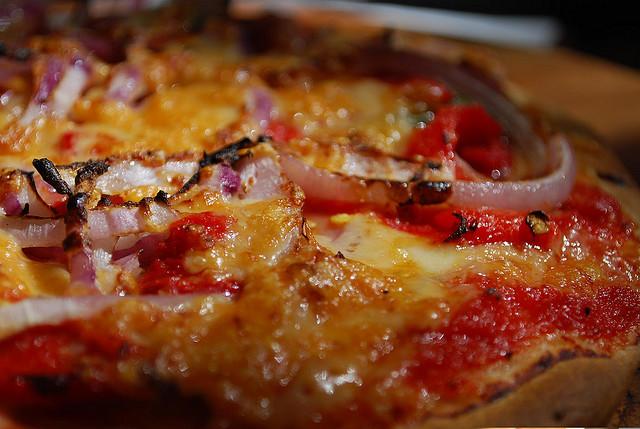Are the onions raw or cooked?
Be succinct. Cooked. Do you like broccoli?
Write a very short answer. No. What kind of food is this?
Keep it brief. Pizza. Why are there some dark spots?
Concise answer only. Burnt. 